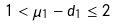<formula> <loc_0><loc_0><loc_500><loc_500>1 < \mu _ { 1 } - d _ { 1 } \leq 2</formula> 